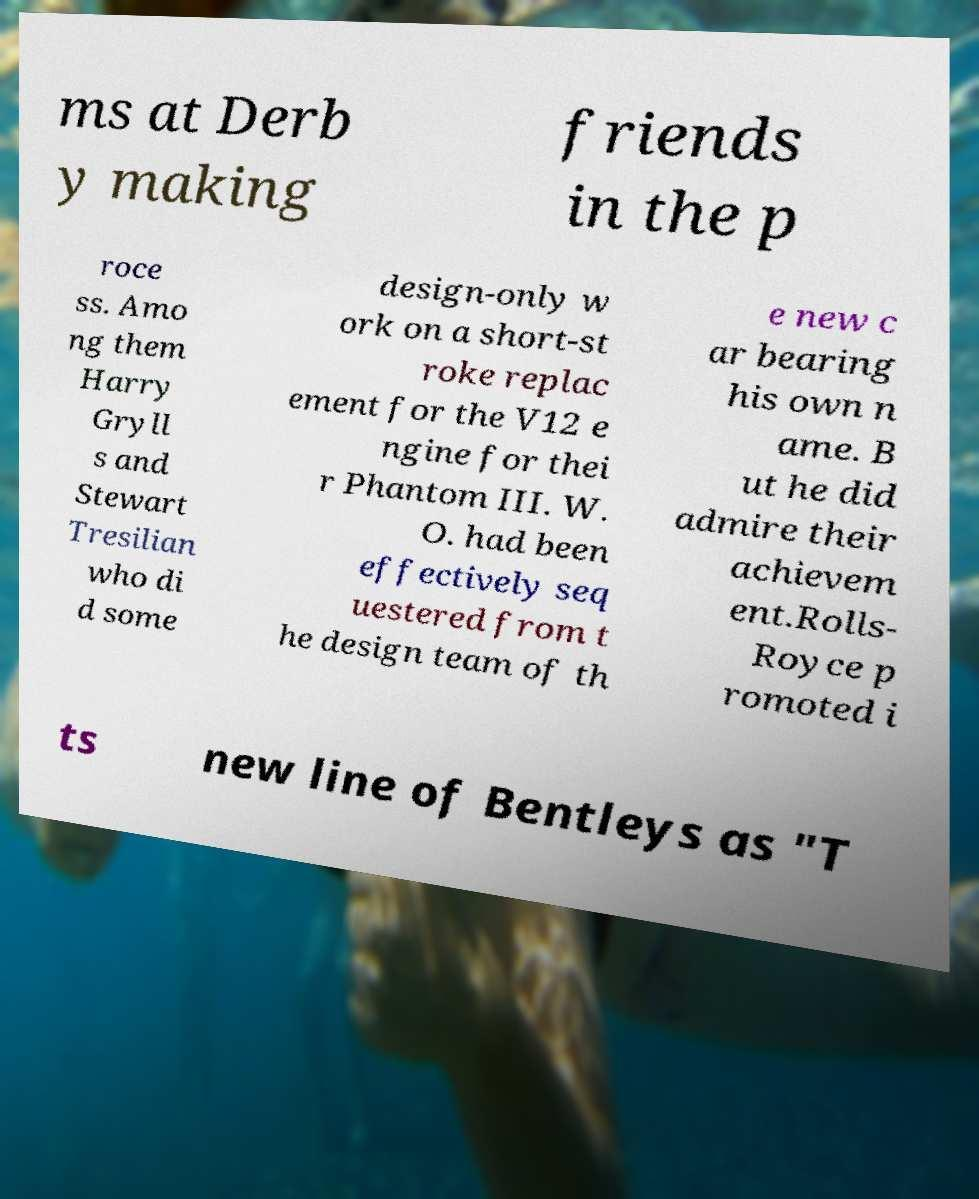Please read and relay the text visible in this image. What does it say? ms at Derb y making friends in the p roce ss. Amo ng them Harry Gryll s and Stewart Tresilian who di d some design-only w ork on a short-st roke replac ement for the V12 e ngine for thei r Phantom III. W. O. had been effectively seq uestered from t he design team of th e new c ar bearing his own n ame. B ut he did admire their achievem ent.Rolls- Royce p romoted i ts new line of Bentleys as "T 